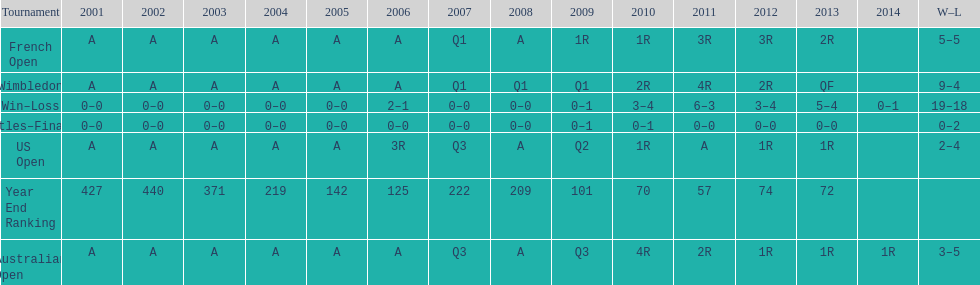What was this players average ranking between 2001 and 2006? 287. 